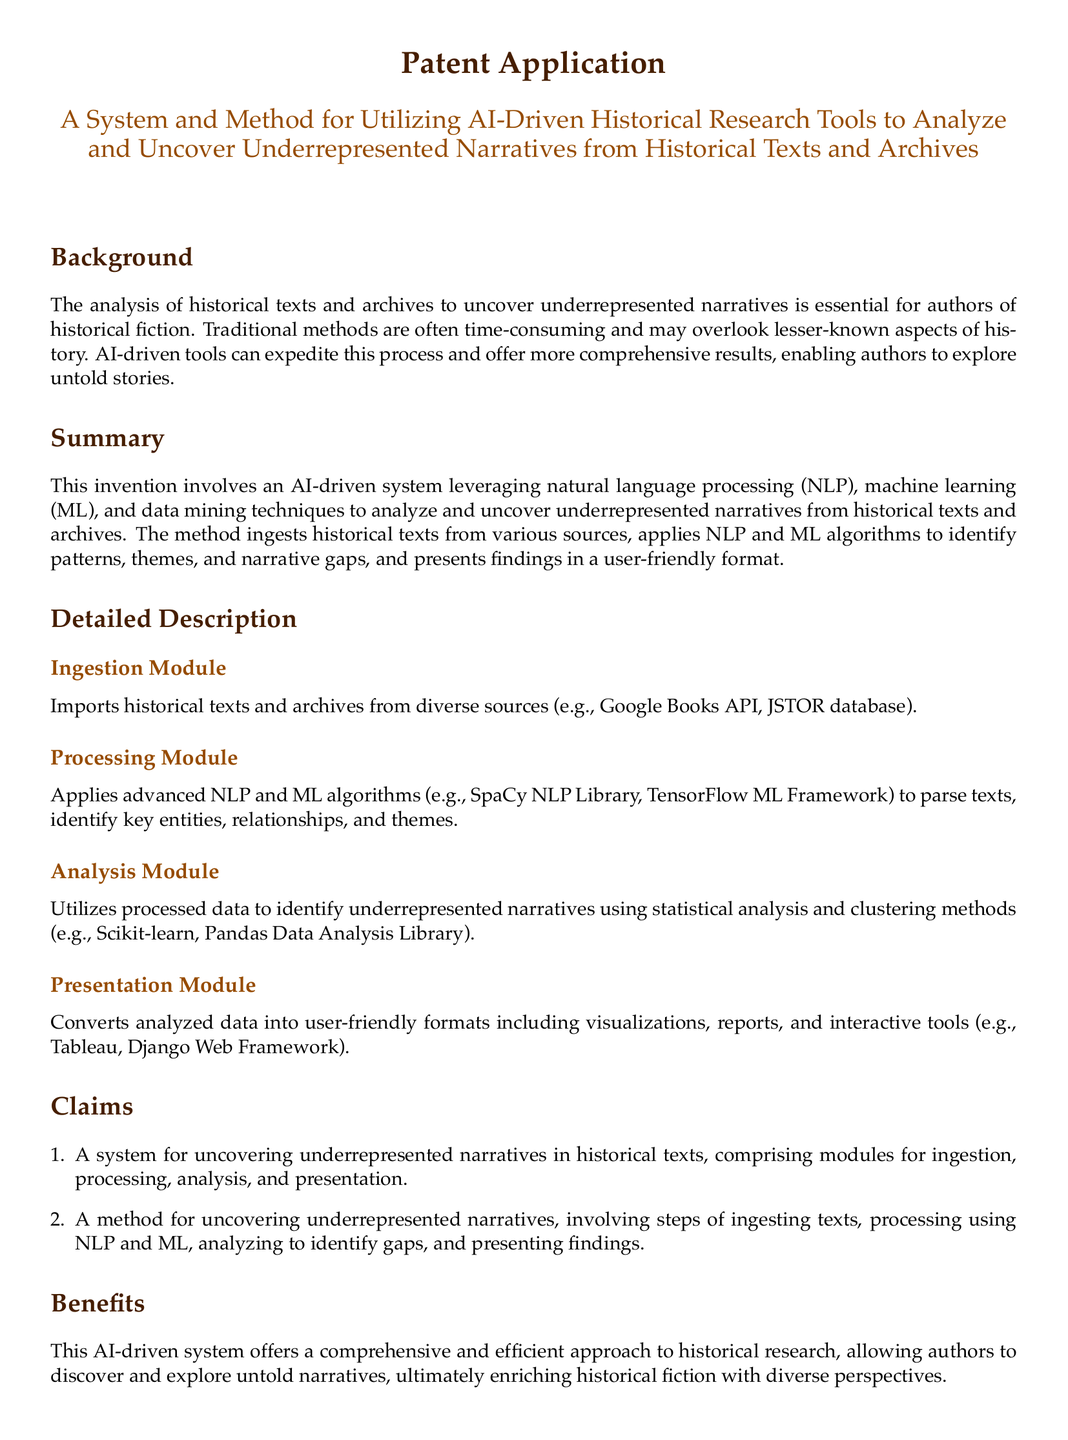What is the title of the patent application? The title is provided under the section that describes the invention.
Answer: A System and Method for Utilizing AI-Driven Historical Research Tools to Analyze and Uncover Underrepresented Narratives from Historical Texts and Archives What are the main modules of the system? The claims section lists the key components of the system clearly.
Answer: Ingestion, Processing, Analysis, Presentation Which library is mentioned for natural language processing? The detailed description mentions a specific library used for NLP.
Answer: SpaCy NLP Library What is one benefit of the AI-driven system? The benefits section provides a key advantage of the proposed system.
Answer: Comprehensive and efficient approach What technology is used for presentation of findings? The detailed description specifies a tool used for presenting data.
Answer: Tableau 